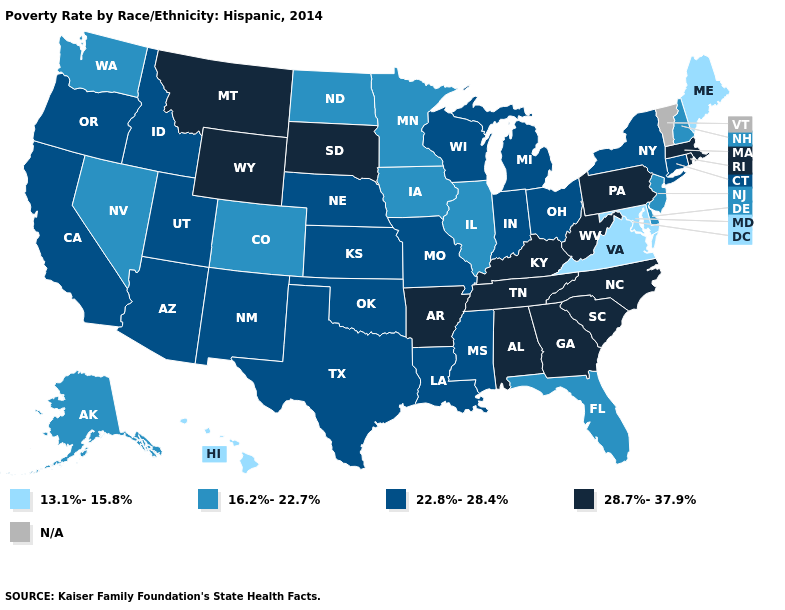Name the states that have a value in the range 13.1%-15.8%?
Write a very short answer. Hawaii, Maine, Maryland, Virginia. Does New York have the lowest value in the Northeast?
Write a very short answer. No. What is the value of Kentucky?
Give a very brief answer. 28.7%-37.9%. Is the legend a continuous bar?
Quick response, please. No. How many symbols are there in the legend?
Be succinct. 5. Which states have the lowest value in the USA?
Answer briefly. Hawaii, Maine, Maryland, Virginia. What is the highest value in the South ?
Write a very short answer. 28.7%-37.9%. Name the states that have a value in the range N/A?
Concise answer only. Vermont. Name the states that have a value in the range 13.1%-15.8%?
Write a very short answer. Hawaii, Maine, Maryland, Virginia. What is the value of Wisconsin?
Answer briefly. 22.8%-28.4%. Name the states that have a value in the range N/A?
Be succinct. Vermont. Which states have the lowest value in the MidWest?
Write a very short answer. Illinois, Iowa, Minnesota, North Dakota. What is the value of Minnesota?
Answer briefly. 16.2%-22.7%. 